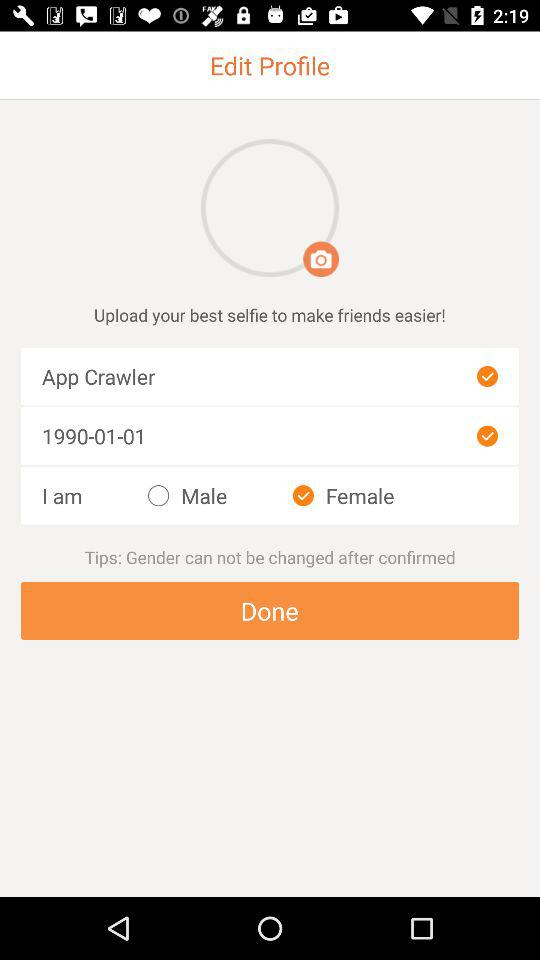Is "Male" selected or not? "Male" is not selected. 